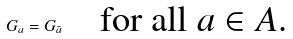Convert formula to latex. <formula><loc_0><loc_0><loc_500><loc_500>G _ { a } = G _ { \bar { a } } \quad \text {for all $a\in A$.}</formula> 